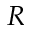Convert formula to latex. <formula><loc_0><loc_0><loc_500><loc_500>R</formula> 